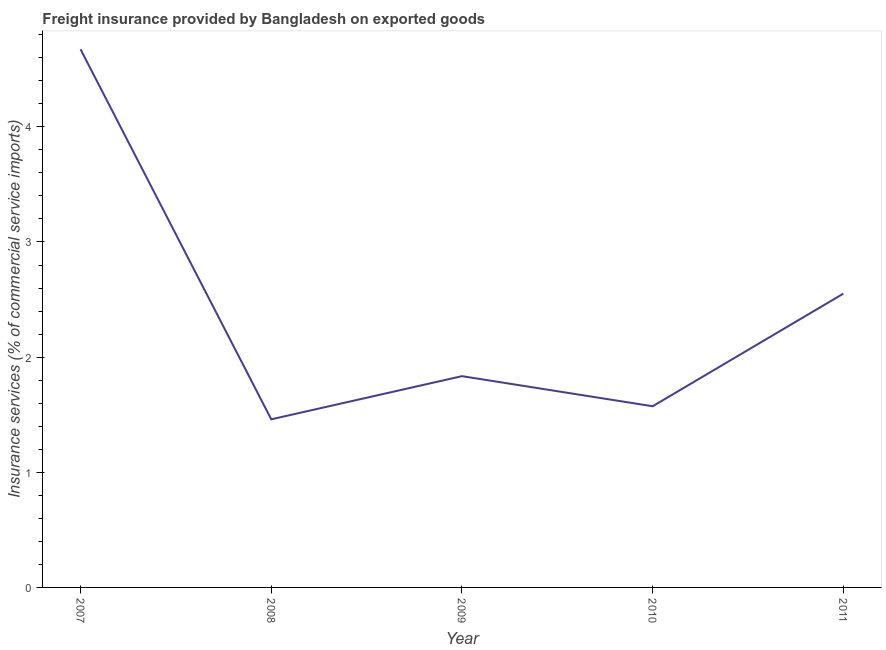What is the freight insurance in 2011?
Provide a short and direct response. 2.55. Across all years, what is the maximum freight insurance?
Your answer should be compact. 4.67. Across all years, what is the minimum freight insurance?
Your response must be concise. 1.46. In which year was the freight insurance maximum?
Your answer should be very brief. 2007. What is the sum of the freight insurance?
Give a very brief answer. 12.09. What is the difference between the freight insurance in 2007 and 2008?
Provide a short and direct response. 3.21. What is the average freight insurance per year?
Your response must be concise. 2.42. What is the median freight insurance?
Offer a terse response. 1.83. What is the ratio of the freight insurance in 2008 to that in 2010?
Your response must be concise. 0.93. Is the freight insurance in 2007 less than that in 2011?
Your response must be concise. No. Is the difference between the freight insurance in 2007 and 2011 greater than the difference between any two years?
Your response must be concise. No. What is the difference between the highest and the second highest freight insurance?
Your answer should be compact. 2.12. Is the sum of the freight insurance in 2008 and 2009 greater than the maximum freight insurance across all years?
Give a very brief answer. No. What is the difference between the highest and the lowest freight insurance?
Give a very brief answer. 3.21. Does the freight insurance monotonically increase over the years?
Your answer should be very brief. No. How many lines are there?
Offer a very short reply. 1. What is the difference between two consecutive major ticks on the Y-axis?
Make the answer very short. 1. What is the title of the graph?
Your answer should be compact. Freight insurance provided by Bangladesh on exported goods . What is the label or title of the X-axis?
Provide a short and direct response. Year. What is the label or title of the Y-axis?
Keep it short and to the point. Insurance services (% of commercial service imports). What is the Insurance services (% of commercial service imports) of 2007?
Offer a very short reply. 4.67. What is the Insurance services (% of commercial service imports) of 2008?
Keep it short and to the point. 1.46. What is the Insurance services (% of commercial service imports) in 2009?
Ensure brevity in your answer.  1.83. What is the Insurance services (% of commercial service imports) in 2010?
Your answer should be compact. 1.57. What is the Insurance services (% of commercial service imports) of 2011?
Provide a short and direct response. 2.55. What is the difference between the Insurance services (% of commercial service imports) in 2007 and 2008?
Ensure brevity in your answer.  3.21. What is the difference between the Insurance services (% of commercial service imports) in 2007 and 2009?
Ensure brevity in your answer.  2.84. What is the difference between the Insurance services (% of commercial service imports) in 2007 and 2010?
Give a very brief answer. 3.1. What is the difference between the Insurance services (% of commercial service imports) in 2007 and 2011?
Your answer should be very brief. 2.12. What is the difference between the Insurance services (% of commercial service imports) in 2008 and 2009?
Your answer should be very brief. -0.37. What is the difference between the Insurance services (% of commercial service imports) in 2008 and 2010?
Keep it short and to the point. -0.11. What is the difference between the Insurance services (% of commercial service imports) in 2008 and 2011?
Your answer should be very brief. -1.09. What is the difference between the Insurance services (% of commercial service imports) in 2009 and 2010?
Offer a very short reply. 0.26. What is the difference between the Insurance services (% of commercial service imports) in 2009 and 2011?
Your answer should be compact. -0.72. What is the difference between the Insurance services (% of commercial service imports) in 2010 and 2011?
Provide a short and direct response. -0.98. What is the ratio of the Insurance services (% of commercial service imports) in 2007 to that in 2008?
Your response must be concise. 3.2. What is the ratio of the Insurance services (% of commercial service imports) in 2007 to that in 2009?
Your response must be concise. 2.55. What is the ratio of the Insurance services (% of commercial service imports) in 2007 to that in 2010?
Offer a very short reply. 2.97. What is the ratio of the Insurance services (% of commercial service imports) in 2007 to that in 2011?
Your answer should be compact. 1.83. What is the ratio of the Insurance services (% of commercial service imports) in 2008 to that in 2009?
Provide a succinct answer. 0.8. What is the ratio of the Insurance services (% of commercial service imports) in 2008 to that in 2010?
Give a very brief answer. 0.93. What is the ratio of the Insurance services (% of commercial service imports) in 2008 to that in 2011?
Your response must be concise. 0.57. What is the ratio of the Insurance services (% of commercial service imports) in 2009 to that in 2010?
Offer a terse response. 1.17. What is the ratio of the Insurance services (% of commercial service imports) in 2009 to that in 2011?
Offer a terse response. 0.72. What is the ratio of the Insurance services (% of commercial service imports) in 2010 to that in 2011?
Provide a short and direct response. 0.62. 